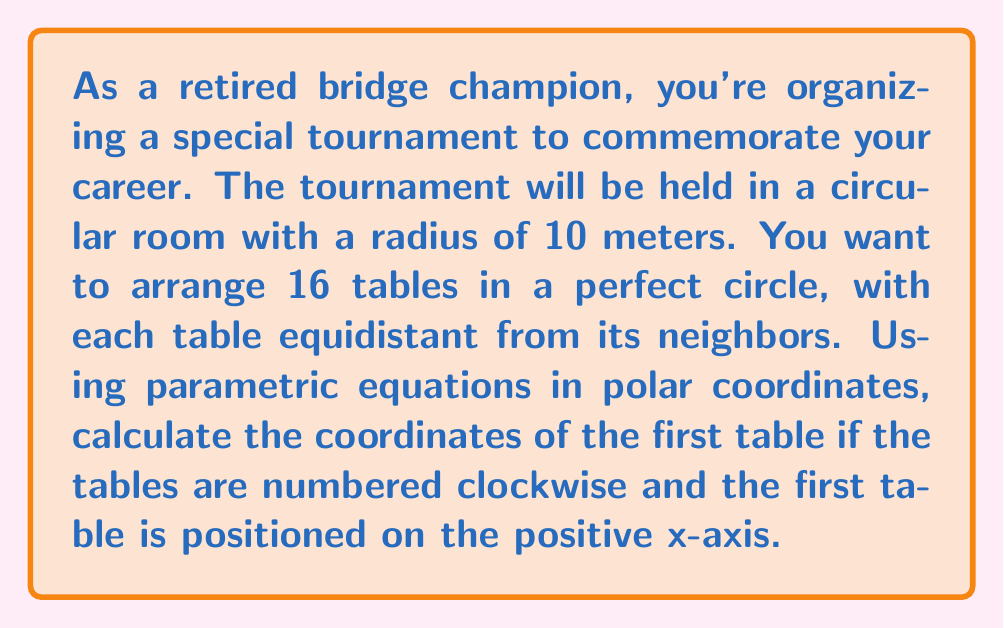Teach me how to tackle this problem. Let's approach this step-by-step:

1) In polar coordinates, we can represent the position of each table using the equation:
   $r = 10$ (since all tables are on the edge of the circular room)
   $\theta = \frac{2\pi k}{n}$, where $k$ is the table number (0 to 15) and $n$ is the total number of tables (16)

2) The parametric equations in polar coordinates are:
   $x = r \cos(\theta)$
   $y = r \sin(\theta)$

3) For the first table (k = 0), we have:
   $\theta = \frac{2\pi \cdot 0}{16} = 0$

4) Substituting into our parametric equations:
   $x = 10 \cos(0) = 10$
   $y = 10 \sin(0) = 0$

5) To verify, we can calculate the position of the second table (k = 1):
   $\theta = \frac{2\pi \cdot 1}{16} = \frac{\pi}{8}$
   $x = 10 \cos(\frac{\pi}{8}) \approx 9.24$
   $y = 10 \sin(\frac{\pi}{8}) \approx 3.83$

This confirms that the tables are indeed arranged in a circle, with the first table on the positive x-axis.

[asy]
import geometry;

size(200);
draw(circle((0,0),10));
for(int i=0; i<16; ++i) {
  real angle = 2*pi*i/16;
  dot((10*cos(angle),10*sin(angle)));
}
draw((0,0)--(10,0),arrow=Arrow(TeXHead));
draw((0,0)--(0,10),arrow=Arrow(TeXHead));
label("x",(10.5,0));
label("y",(0,10.5));
label("(10,0)",(10,-0.5));
[/asy]
Answer: The coordinates of the first table are (10, 0) in Cartesian coordinates, or $(r,\theta) = (10,0)$ in polar coordinates. 